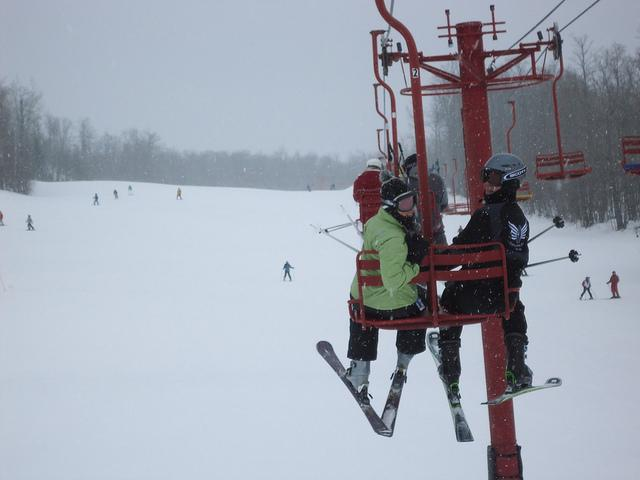Why are they so high up? Please explain your reasoning. carrying uphill. They are carrying them uphill. 